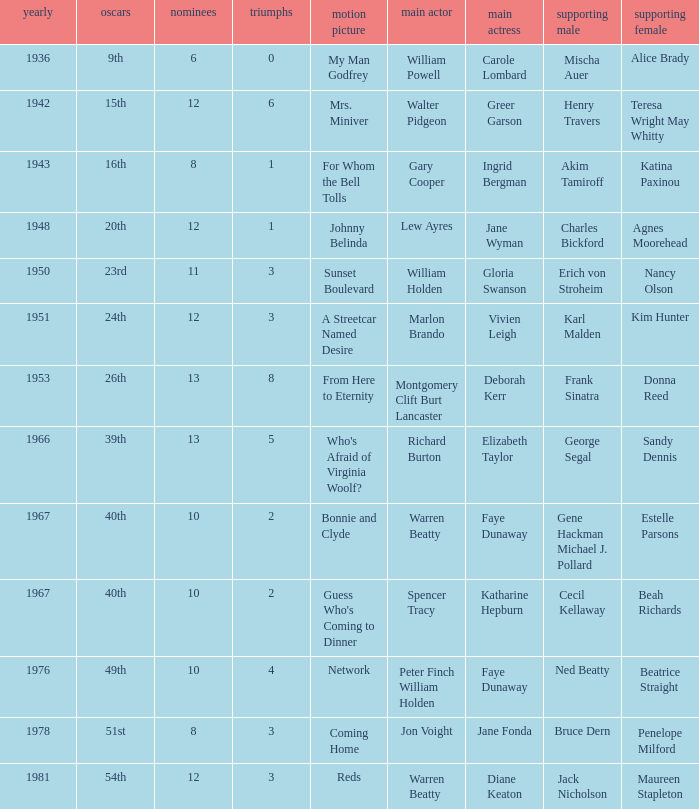Who was the backup actress in a movie where diane keaton was the primary actress? Maureen Stapleton. 